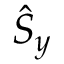Convert formula to latex. <formula><loc_0><loc_0><loc_500><loc_500>\hat { S } _ { y }</formula> 